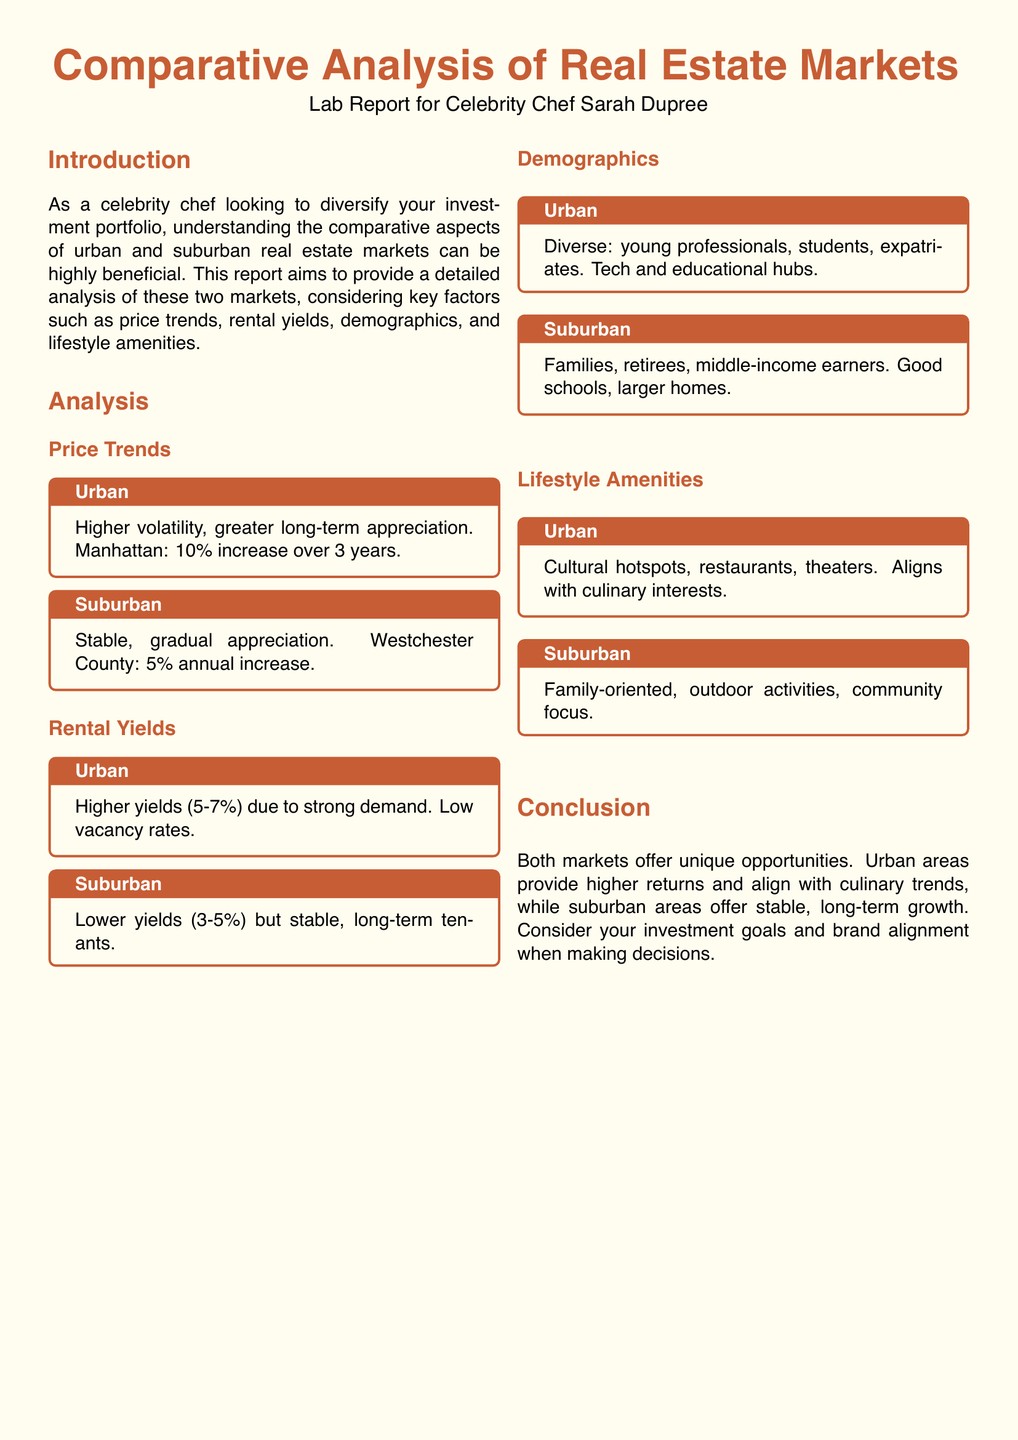what is the price trend increase for Manhattan over 3 years? The document states that Manhattan has seen a 10% increase over 3 years.
Answer: 10% what is the annual increase percentage for Westchester County? The report indicates that Westchester County has a 5% annual increase.
Answer: 5% what are the rental yield percentages for urban areas? The document specifies that urban areas have higher yields of 5-7%.
Answer: 5-7% who are the primary demographics in urban areas? According to the analysis, the demographics in urban areas include young professionals, students, and expatriates.
Answer: young professionals, students, expatriates which type of market offers stable, long-term growth? The document highlights that suburban areas provide stable, long-term growth.
Answer: suburban what amenities do urban areas provide that align with culinary interests? The report notes that urban areas feature cultural hotspots, restaurants, and theaters.
Answer: cultural hotspots, restaurants, theaters what is the primary demographic in suburban areas? The document states that suburban areas primarily attract families, retirees, and middle-income earners.
Answer: families, retirees, middle-income earners what is the purpose of this lab report? The report aims to provide a comparative analysis of urban and suburban real estate markets.
Answer: comparative analysis of urban and suburban real estate markets 